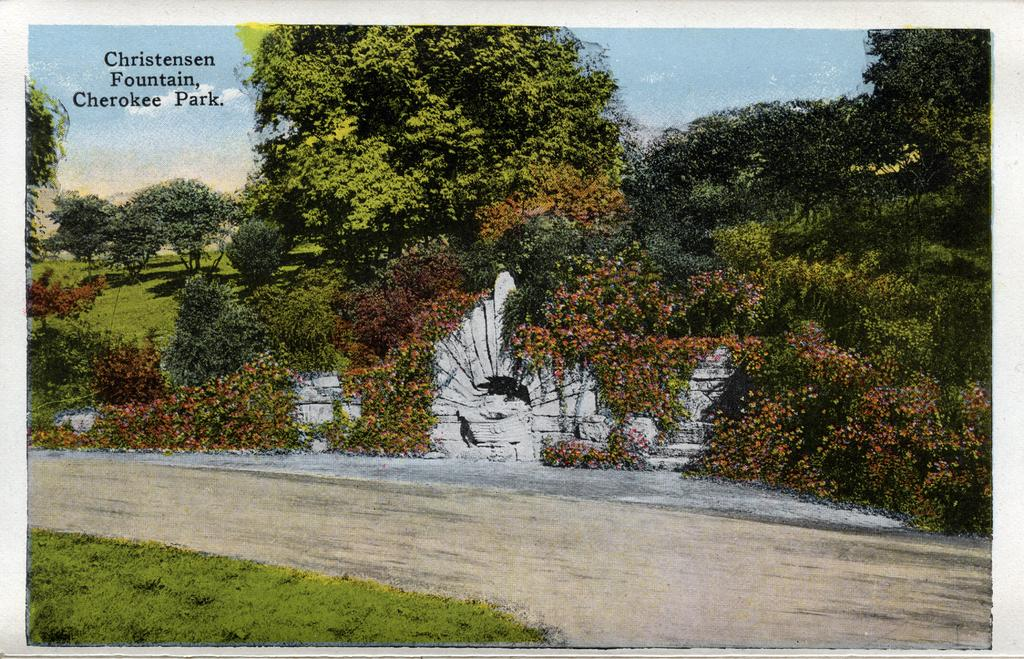What is the main subject of the image? The main subject of the image is a photograph of a park. What can be seen in the foreground of the image? There are many trees in the front of the image. What is the color and size of the wall in the middle of the image? The wall is small and white in color. What type of paste is being used to stick the trees together in the image? There is no paste or any indication of trees being stuck together in the image; they are naturally growing in the park. 